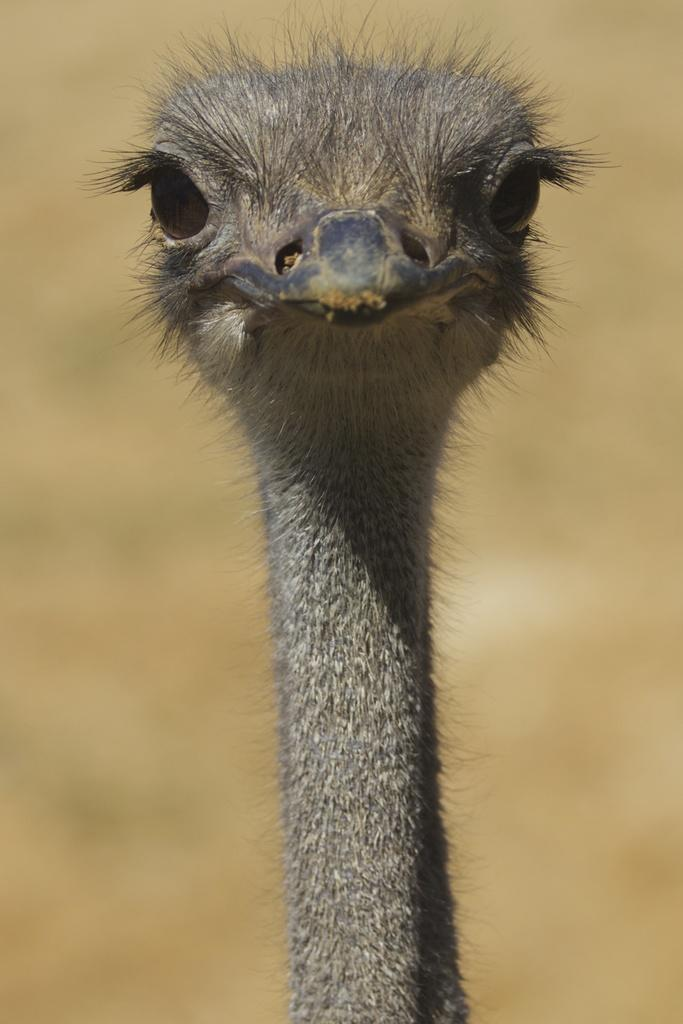What part of an ostrich is visible in the image? The neck of an ostrich is visible in the image. Can you describe the background of the image? The background of the image is blurred. What train route can be seen in the image? There is no train or route present in the image; it features the neck of an ostrich with a blurred background. How many women are visible in the image? There are no women present in the image. 